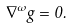<formula> <loc_0><loc_0><loc_500><loc_500>\nabla ^ { \omega } g = 0 .</formula> 